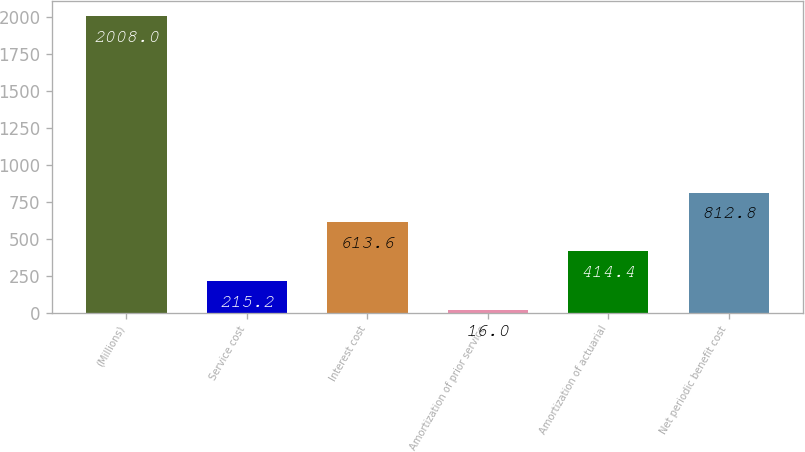Convert chart. <chart><loc_0><loc_0><loc_500><loc_500><bar_chart><fcel>(Millions)<fcel>Service cost<fcel>Interest cost<fcel>Amortization of prior service<fcel>Amortization of actuarial<fcel>Net periodic benefit cost<nl><fcel>2008<fcel>215.2<fcel>613.6<fcel>16<fcel>414.4<fcel>812.8<nl></chart> 